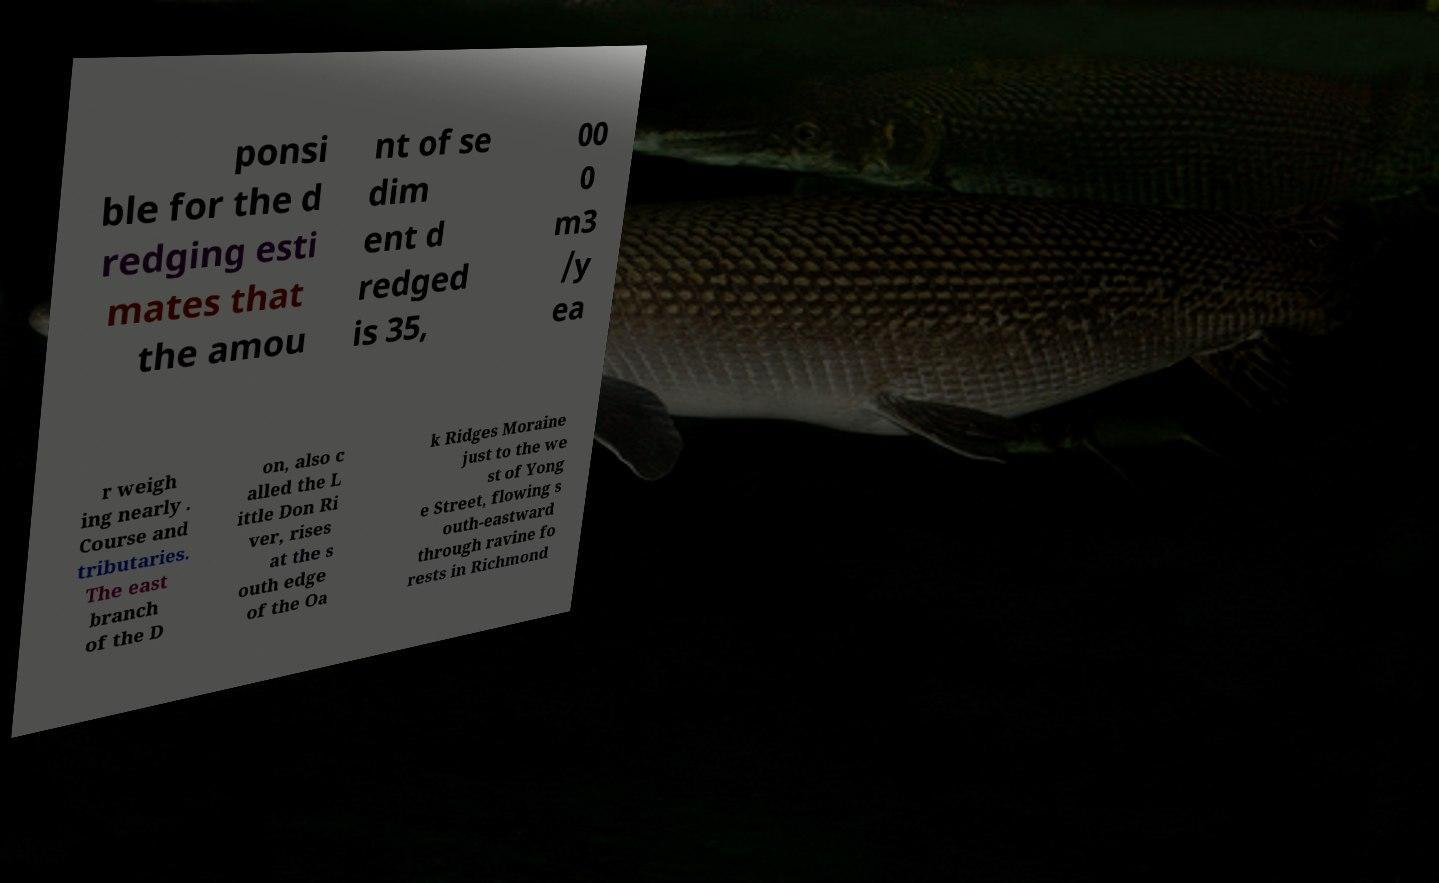For documentation purposes, I need the text within this image transcribed. Could you provide that? ponsi ble for the d redging esti mates that the amou nt of se dim ent d redged is 35, 00 0 m3 /y ea r weigh ing nearly . Course and tributaries. The east branch of the D on, also c alled the L ittle Don Ri ver, rises at the s outh edge of the Oa k Ridges Moraine just to the we st of Yong e Street, flowing s outh-eastward through ravine fo rests in Richmond 